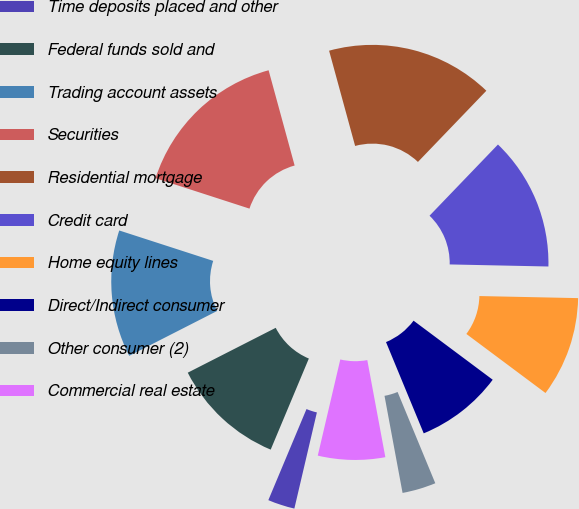<chart> <loc_0><loc_0><loc_500><loc_500><pie_chart><fcel>Time deposits placed and other<fcel>Federal funds sold and<fcel>Trading account assets<fcel>Securities<fcel>Residential mortgage<fcel>Credit card<fcel>Home equity lines<fcel>Direct/Indirect consumer<fcel>Other consumer (2)<fcel>Commercial real estate<nl><fcel>2.65%<fcel>11.18%<fcel>12.49%<fcel>15.77%<fcel>16.43%<fcel>13.15%<fcel>9.87%<fcel>8.56%<fcel>3.31%<fcel>6.59%<nl></chart> 